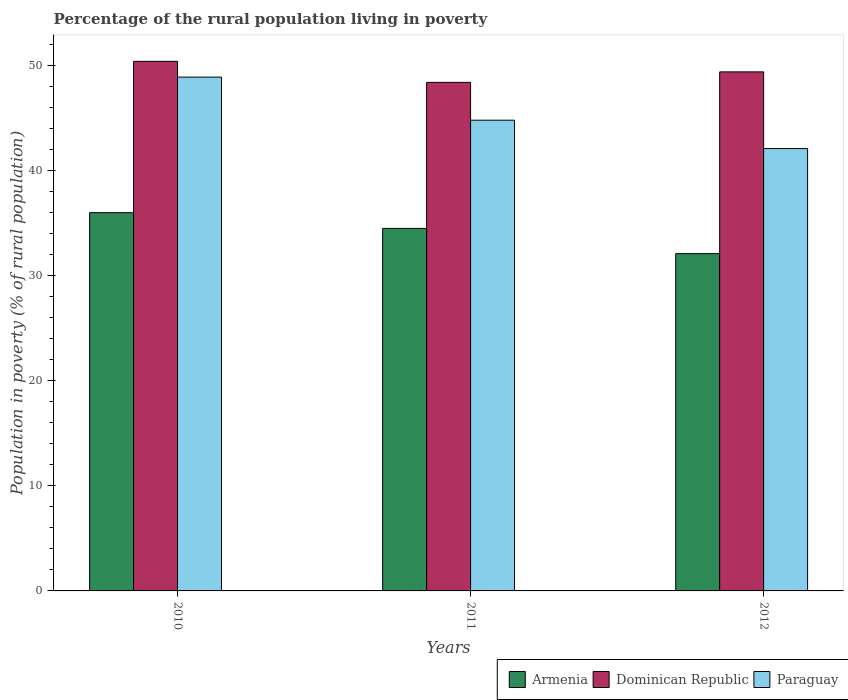How many bars are there on the 2nd tick from the right?
Keep it short and to the point. 3. In how many cases, is the number of bars for a given year not equal to the number of legend labels?
Make the answer very short. 0. What is the percentage of the rural population living in poverty in Paraguay in 2011?
Offer a terse response. 44.8. Across all years, what is the maximum percentage of the rural population living in poverty in Paraguay?
Your answer should be very brief. 48.9. Across all years, what is the minimum percentage of the rural population living in poverty in Paraguay?
Make the answer very short. 42.1. What is the total percentage of the rural population living in poverty in Paraguay in the graph?
Provide a short and direct response. 135.8. What is the difference between the percentage of the rural population living in poverty in Armenia in 2010 and that in 2012?
Provide a succinct answer. 3.9. What is the difference between the percentage of the rural population living in poverty in Armenia in 2010 and the percentage of the rural population living in poverty in Dominican Republic in 2012?
Make the answer very short. -13.4. What is the average percentage of the rural population living in poverty in Armenia per year?
Your response must be concise. 34.2. In the year 2012, what is the difference between the percentage of the rural population living in poverty in Armenia and percentage of the rural population living in poverty in Paraguay?
Give a very brief answer. -10. What is the ratio of the percentage of the rural population living in poverty in Dominican Republic in 2010 to that in 2012?
Offer a terse response. 1.02. Is the difference between the percentage of the rural population living in poverty in Armenia in 2010 and 2011 greater than the difference between the percentage of the rural population living in poverty in Paraguay in 2010 and 2011?
Give a very brief answer. No. What is the difference between the highest and the second highest percentage of the rural population living in poverty in Paraguay?
Give a very brief answer. 4.1. What is the difference between the highest and the lowest percentage of the rural population living in poverty in Paraguay?
Make the answer very short. 6.8. In how many years, is the percentage of the rural population living in poverty in Dominican Republic greater than the average percentage of the rural population living in poverty in Dominican Republic taken over all years?
Keep it short and to the point. 1. Is the sum of the percentage of the rural population living in poverty in Paraguay in 2010 and 2012 greater than the maximum percentage of the rural population living in poverty in Armenia across all years?
Your answer should be very brief. Yes. What does the 2nd bar from the left in 2010 represents?
Provide a short and direct response. Dominican Republic. What does the 1st bar from the right in 2010 represents?
Offer a very short reply. Paraguay. What is the difference between two consecutive major ticks on the Y-axis?
Your response must be concise. 10. Are the values on the major ticks of Y-axis written in scientific E-notation?
Your answer should be compact. No. Does the graph contain any zero values?
Provide a succinct answer. No. Does the graph contain grids?
Your response must be concise. No. Where does the legend appear in the graph?
Keep it short and to the point. Bottom right. What is the title of the graph?
Your answer should be very brief. Percentage of the rural population living in poverty. Does "Belize" appear as one of the legend labels in the graph?
Your response must be concise. No. What is the label or title of the Y-axis?
Keep it short and to the point. Population in poverty (% of rural population). What is the Population in poverty (% of rural population) of Dominican Republic in 2010?
Provide a short and direct response. 50.4. What is the Population in poverty (% of rural population) of Paraguay in 2010?
Make the answer very short. 48.9. What is the Population in poverty (% of rural population) of Armenia in 2011?
Give a very brief answer. 34.5. What is the Population in poverty (% of rural population) in Dominican Republic in 2011?
Make the answer very short. 48.4. What is the Population in poverty (% of rural population) of Paraguay in 2011?
Provide a short and direct response. 44.8. What is the Population in poverty (% of rural population) in Armenia in 2012?
Make the answer very short. 32.1. What is the Population in poverty (% of rural population) of Dominican Republic in 2012?
Ensure brevity in your answer.  49.4. What is the Population in poverty (% of rural population) of Paraguay in 2012?
Offer a terse response. 42.1. Across all years, what is the maximum Population in poverty (% of rural population) of Armenia?
Offer a very short reply. 36. Across all years, what is the maximum Population in poverty (% of rural population) in Dominican Republic?
Ensure brevity in your answer.  50.4. Across all years, what is the maximum Population in poverty (% of rural population) of Paraguay?
Your response must be concise. 48.9. Across all years, what is the minimum Population in poverty (% of rural population) of Armenia?
Ensure brevity in your answer.  32.1. Across all years, what is the minimum Population in poverty (% of rural population) in Dominican Republic?
Your response must be concise. 48.4. Across all years, what is the minimum Population in poverty (% of rural population) in Paraguay?
Keep it short and to the point. 42.1. What is the total Population in poverty (% of rural population) in Armenia in the graph?
Offer a very short reply. 102.6. What is the total Population in poverty (% of rural population) in Dominican Republic in the graph?
Keep it short and to the point. 148.2. What is the total Population in poverty (% of rural population) in Paraguay in the graph?
Offer a very short reply. 135.8. What is the difference between the Population in poverty (% of rural population) in Armenia in 2010 and that in 2011?
Ensure brevity in your answer.  1.5. What is the difference between the Population in poverty (% of rural population) in Armenia in 2011 and that in 2012?
Provide a succinct answer. 2.4. What is the difference between the Population in poverty (% of rural population) of Armenia in 2010 and the Population in poverty (% of rural population) of Paraguay in 2011?
Ensure brevity in your answer.  -8.8. What is the difference between the Population in poverty (% of rural population) in Dominican Republic in 2010 and the Population in poverty (% of rural population) in Paraguay in 2011?
Provide a short and direct response. 5.6. What is the difference between the Population in poverty (% of rural population) in Dominican Republic in 2010 and the Population in poverty (% of rural population) in Paraguay in 2012?
Give a very brief answer. 8.3. What is the difference between the Population in poverty (% of rural population) in Armenia in 2011 and the Population in poverty (% of rural population) in Dominican Republic in 2012?
Offer a terse response. -14.9. What is the average Population in poverty (% of rural population) in Armenia per year?
Provide a short and direct response. 34.2. What is the average Population in poverty (% of rural population) in Dominican Republic per year?
Provide a short and direct response. 49.4. What is the average Population in poverty (% of rural population) in Paraguay per year?
Provide a succinct answer. 45.27. In the year 2010, what is the difference between the Population in poverty (% of rural population) of Armenia and Population in poverty (% of rural population) of Dominican Republic?
Make the answer very short. -14.4. In the year 2010, what is the difference between the Population in poverty (% of rural population) of Armenia and Population in poverty (% of rural population) of Paraguay?
Your response must be concise. -12.9. In the year 2010, what is the difference between the Population in poverty (% of rural population) in Dominican Republic and Population in poverty (% of rural population) in Paraguay?
Make the answer very short. 1.5. In the year 2011, what is the difference between the Population in poverty (% of rural population) in Armenia and Population in poverty (% of rural population) in Paraguay?
Make the answer very short. -10.3. In the year 2011, what is the difference between the Population in poverty (% of rural population) of Dominican Republic and Population in poverty (% of rural population) of Paraguay?
Keep it short and to the point. 3.6. In the year 2012, what is the difference between the Population in poverty (% of rural population) of Armenia and Population in poverty (% of rural population) of Dominican Republic?
Ensure brevity in your answer.  -17.3. In the year 2012, what is the difference between the Population in poverty (% of rural population) of Armenia and Population in poverty (% of rural population) of Paraguay?
Your response must be concise. -10. In the year 2012, what is the difference between the Population in poverty (% of rural population) of Dominican Republic and Population in poverty (% of rural population) of Paraguay?
Your response must be concise. 7.3. What is the ratio of the Population in poverty (% of rural population) of Armenia in 2010 to that in 2011?
Give a very brief answer. 1.04. What is the ratio of the Population in poverty (% of rural population) of Dominican Republic in 2010 to that in 2011?
Provide a short and direct response. 1.04. What is the ratio of the Population in poverty (% of rural population) in Paraguay in 2010 to that in 2011?
Your answer should be very brief. 1.09. What is the ratio of the Population in poverty (% of rural population) in Armenia in 2010 to that in 2012?
Your answer should be very brief. 1.12. What is the ratio of the Population in poverty (% of rural population) in Dominican Republic in 2010 to that in 2012?
Make the answer very short. 1.02. What is the ratio of the Population in poverty (% of rural population) in Paraguay in 2010 to that in 2012?
Offer a terse response. 1.16. What is the ratio of the Population in poverty (% of rural population) in Armenia in 2011 to that in 2012?
Provide a short and direct response. 1.07. What is the ratio of the Population in poverty (% of rural population) of Dominican Republic in 2011 to that in 2012?
Your response must be concise. 0.98. What is the ratio of the Population in poverty (% of rural population) of Paraguay in 2011 to that in 2012?
Provide a succinct answer. 1.06. What is the difference between the highest and the second highest Population in poverty (% of rural population) in Dominican Republic?
Your response must be concise. 1. What is the difference between the highest and the lowest Population in poverty (% of rural population) of Dominican Republic?
Offer a terse response. 2. 